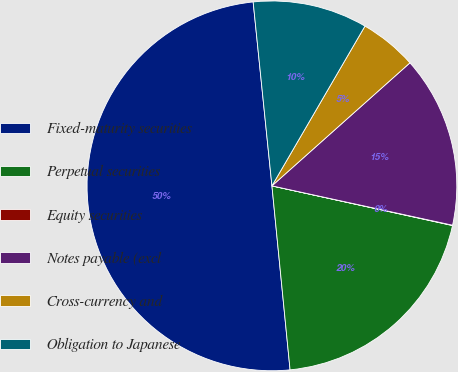Convert chart to OTSL. <chart><loc_0><loc_0><loc_500><loc_500><pie_chart><fcel>Fixed-maturity securities<fcel>Perpetual securities<fcel>Equity securities<fcel>Notes payable (excl<fcel>Cross-currency and<fcel>Obligation to Japanese<nl><fcel>49.94%<fcel>19.99%<fcel>0.03%<fcel>15.0%<fcel>5.02%<fcel>10.01%<nl></chart> 